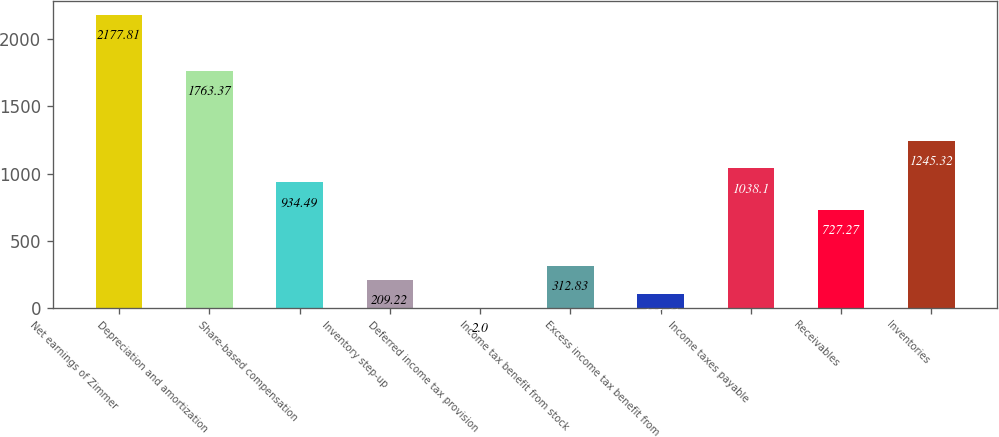<chart> <loc_0><loc_0><loc_500><loc_500><bar_chart><fcel>Net earnings of Zimmer<fcel>Depreciation and amortization<fcel>Share-based compensation<fcel>Inventory step-up<fcel>Deferred income tax provision<fcel>Income tax benefit from stock<fcel>Excess income tax benefit from<fcel>Income taxes payable<fcel>Receivables<fcel>Inventories<nl><fcel>2177.81<fcel>1763.37<fcel>934.49<fcel>209.22<fcel>2<fcel>312.83<fcel>105.61<fcel>1038.1<fcel>727.27<fcel>1245.32<nl></chart> 